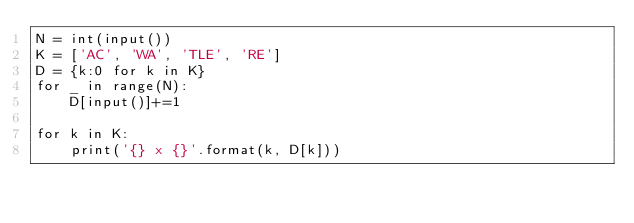Convert code to text. <code><loc_0><loc_0><loc_500><loc_500><_Python_>N = int(input())
K = ['AC', 'WA', 'TLE', 'RE']
D = {k:0 for k in K}
for _ in range(N):
    D[input()]+=1

for k in K:
    print('{} x {}'.format(k, D[k]))</code> 